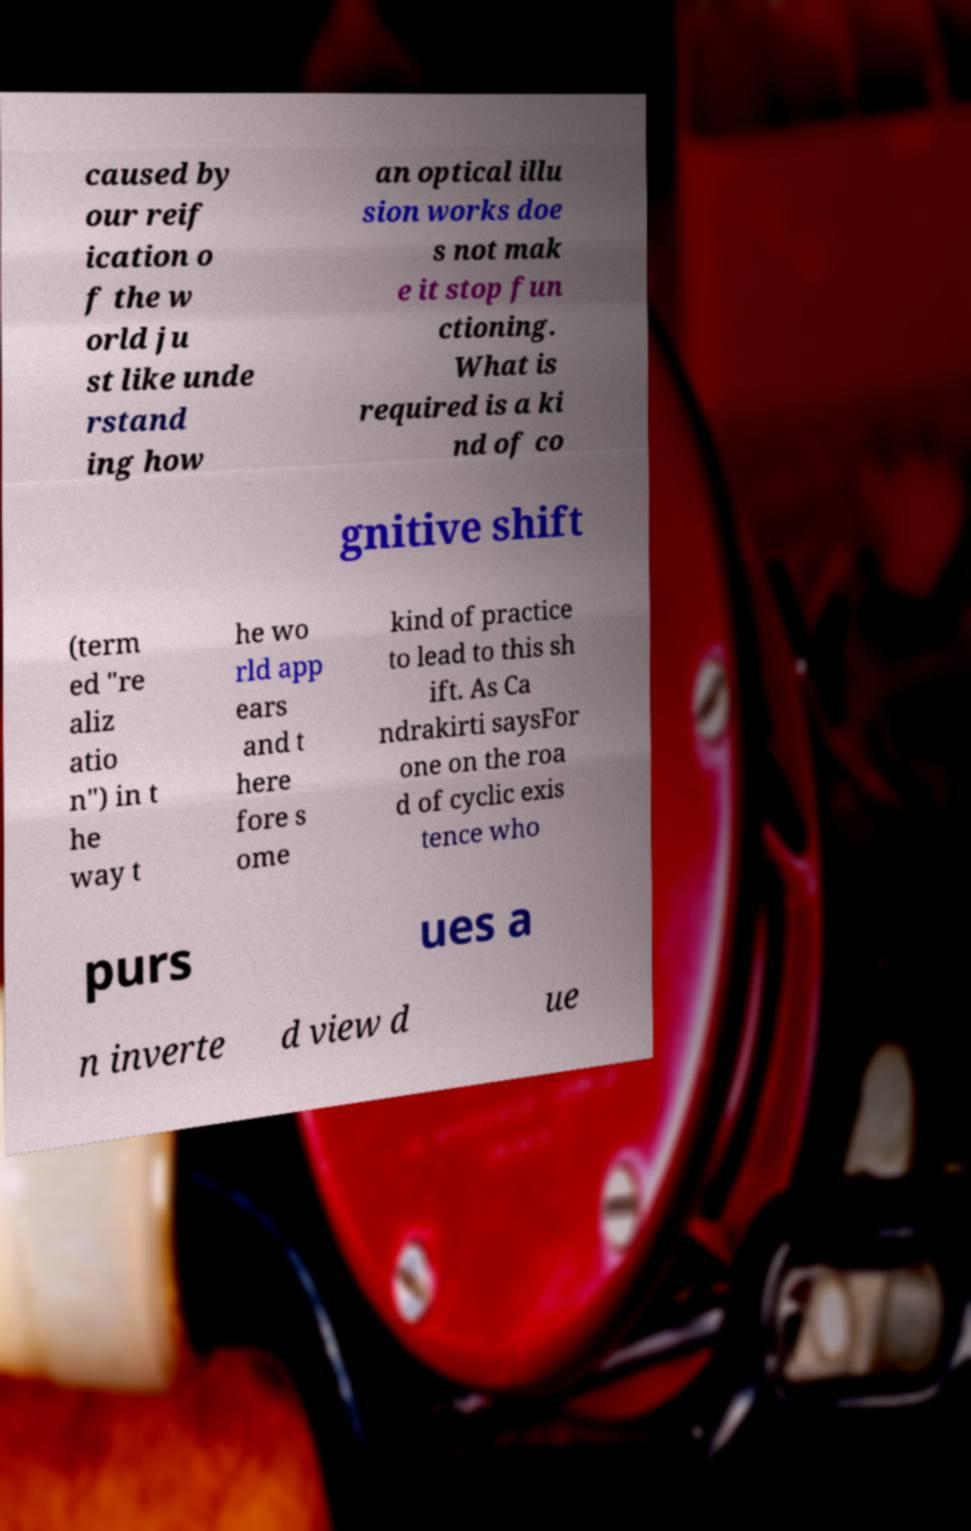Could you extract and type out the text from this image? caused by our reif ication o f the w orld ju st like unde rstand ing how an optical illu sion works doe s not mak e it stop fun ctioning. What is required is a ki nd of co gnitive shift (term ed "re aliz atio n") in t he way t he wo rld app ears and t here fore s ome kind of practice to lead to this sh ift. As Ca ndrakirti saysFor one on the roa d of cyclic exis tence who purs ues a n inverte d view d ue 